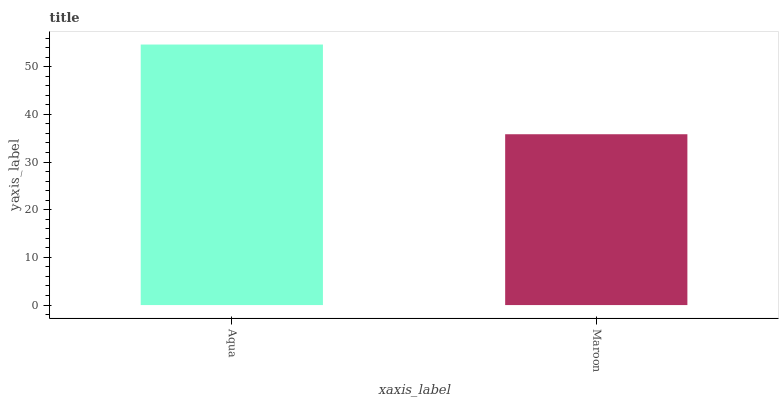Is Maroon the minimum?
Answer yes or no. Yes. Is Aqua the maximum?
Answer yes or no. Yes. Is Maroon the maximum?
Answer yes or no. No. Is Aqua greater than Maroon?
Answer yes or no. Yes. Is Maroon less than Aqua?
Answer yes or no. Yes. Is Maroon greater than Aqua?
Answer yes or no. No. Is Aqua less than Maroon?
Answer yes or no. No. Is Aqua the high median?
Answer yes or no. Yes. Is Maroon the low median?
Answer yes or no. Yes. Is Maroon the high median?
Answer yes or no. No. Is Aqua the low median?
Answer yes or no. No. 